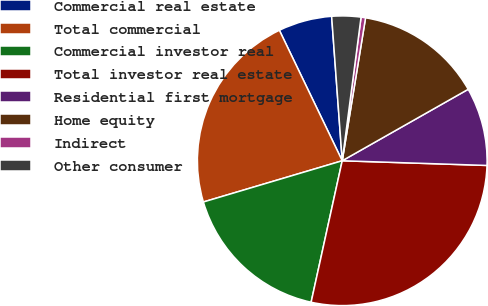<chart> <loc_0><loc_0><loc_500><loc_500><pie_chart><fcel>Commercial real estate<fcel>Total commercial<fcel>Commercial investor real<fcel>Total investor real estate<fcel>Residential first mortgage<fcel>Home equity<fcel>Indirect<fcel>Other consumer<nl><fcel>5.98%<fcel>22.45%<fcel>16.96%<fcel>27.93%<fcel>8.73%<fcel>14.21%<fcel>0.5%<fcel>3.24%<nl></chart> 